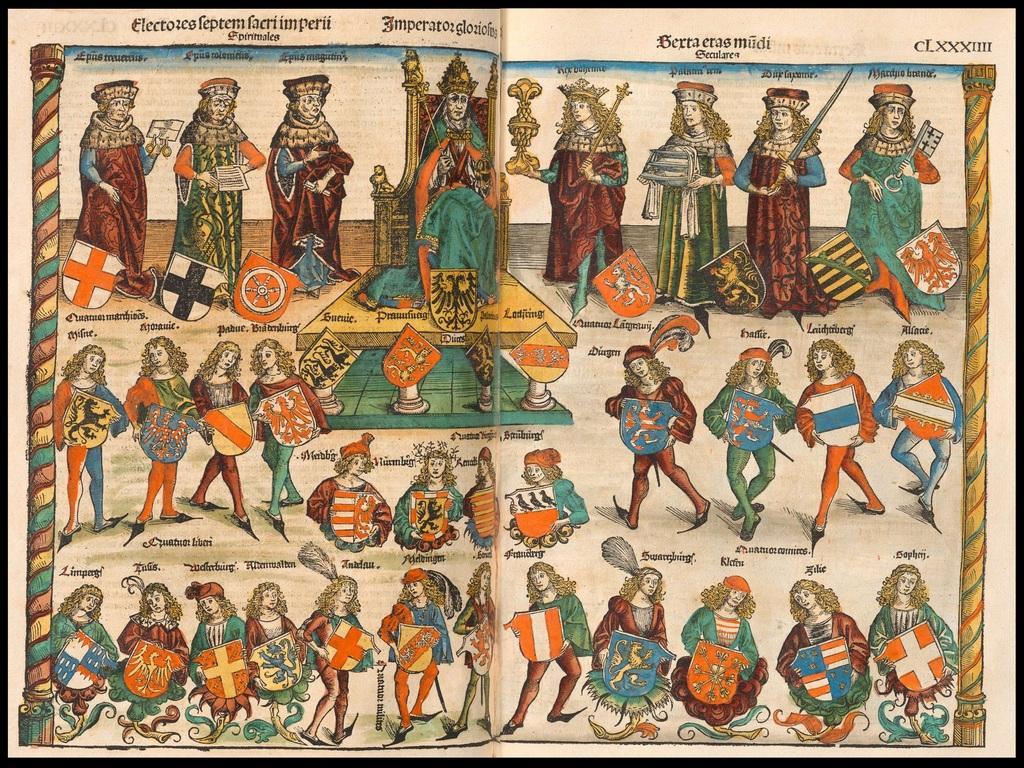Can you describe this image briefly? In this image we can see a paper with paintings and some text. 